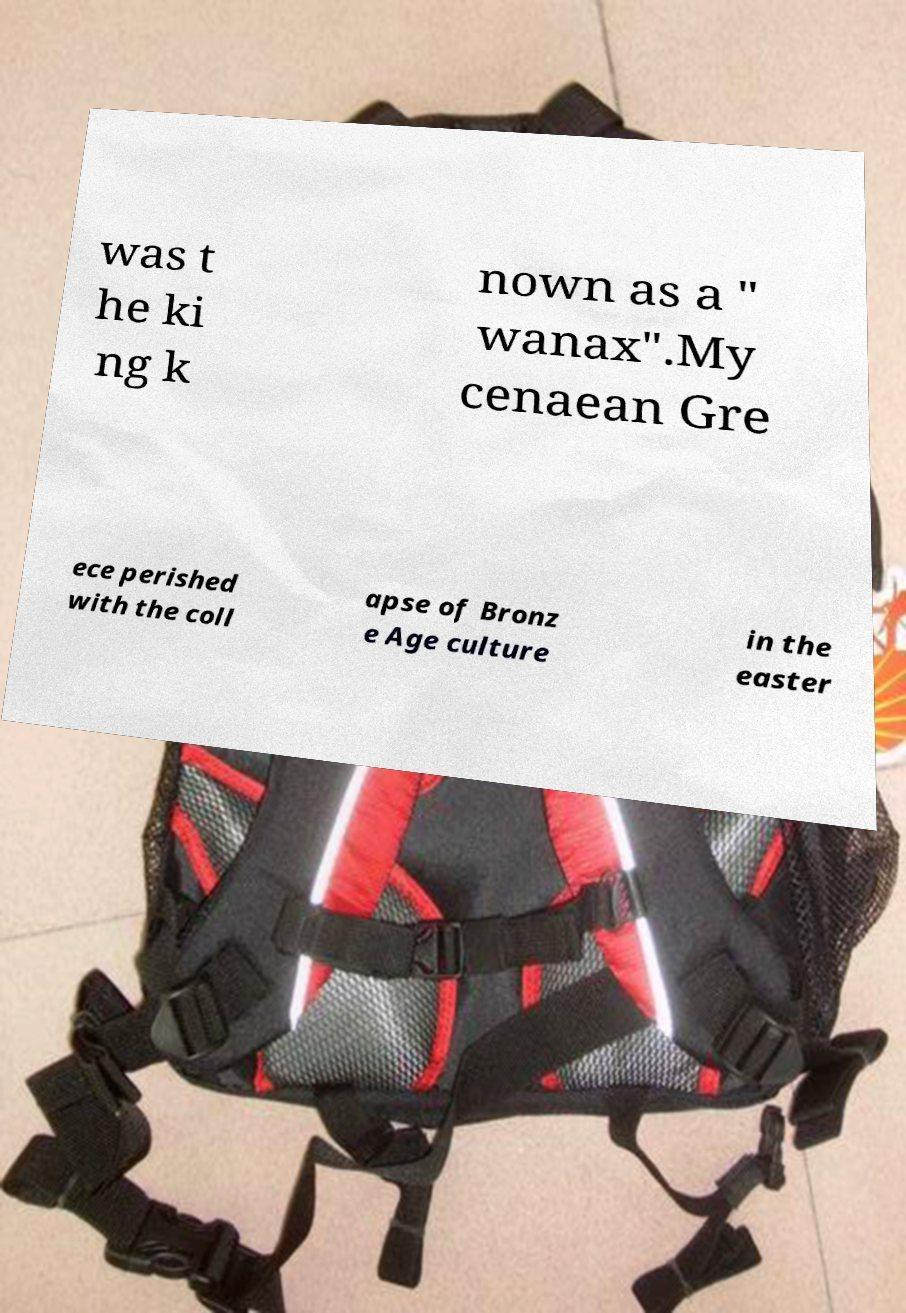Can you accurately transcribe the text from the provided image for me? was t he ki ng k nown as a " wanax".My cenaean Gre ece perished with the coll apse of Bronz e Age culture in the easter 